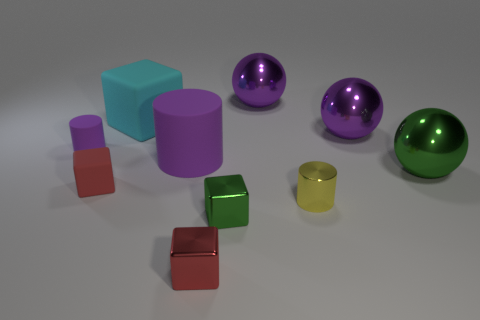Subtract all purple cylinders. How many cylinders are left? 1 Subtract all purple spheres. How many spheres are left? 1 Subtract all purple balls. Subtract all large green metal objects. How many objects are left? 7 Add 1 small objects. How many small objects are left? 6 Add 4 red shiny cubes. How many red shiny cubes exist? 5 Subtract 0 gray spheres. How many objects are left? 10 Subtract all cylinders. How many objects are left? 7 Subtract 1 cylinders. How many cylinders are left? 2 Subtract all gray spheres. Subtract all brown cubes. How many spheres are left? 3 Subtract all brown cylinders. How many gray blocks are left? 0 